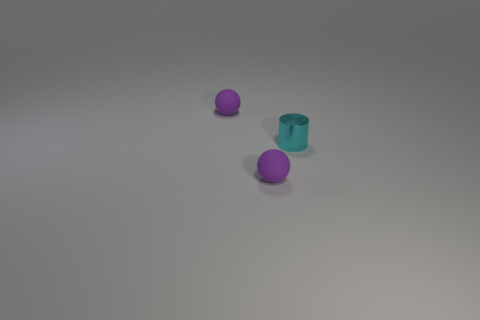Is there any indication of the size of these objects? Without a common reference object in the image, it is difficult to determine the exact size of these objects. However, considering their proportions relative to each other, one might infer they are small, possibly comparable to household items like a cup or a small ball. 